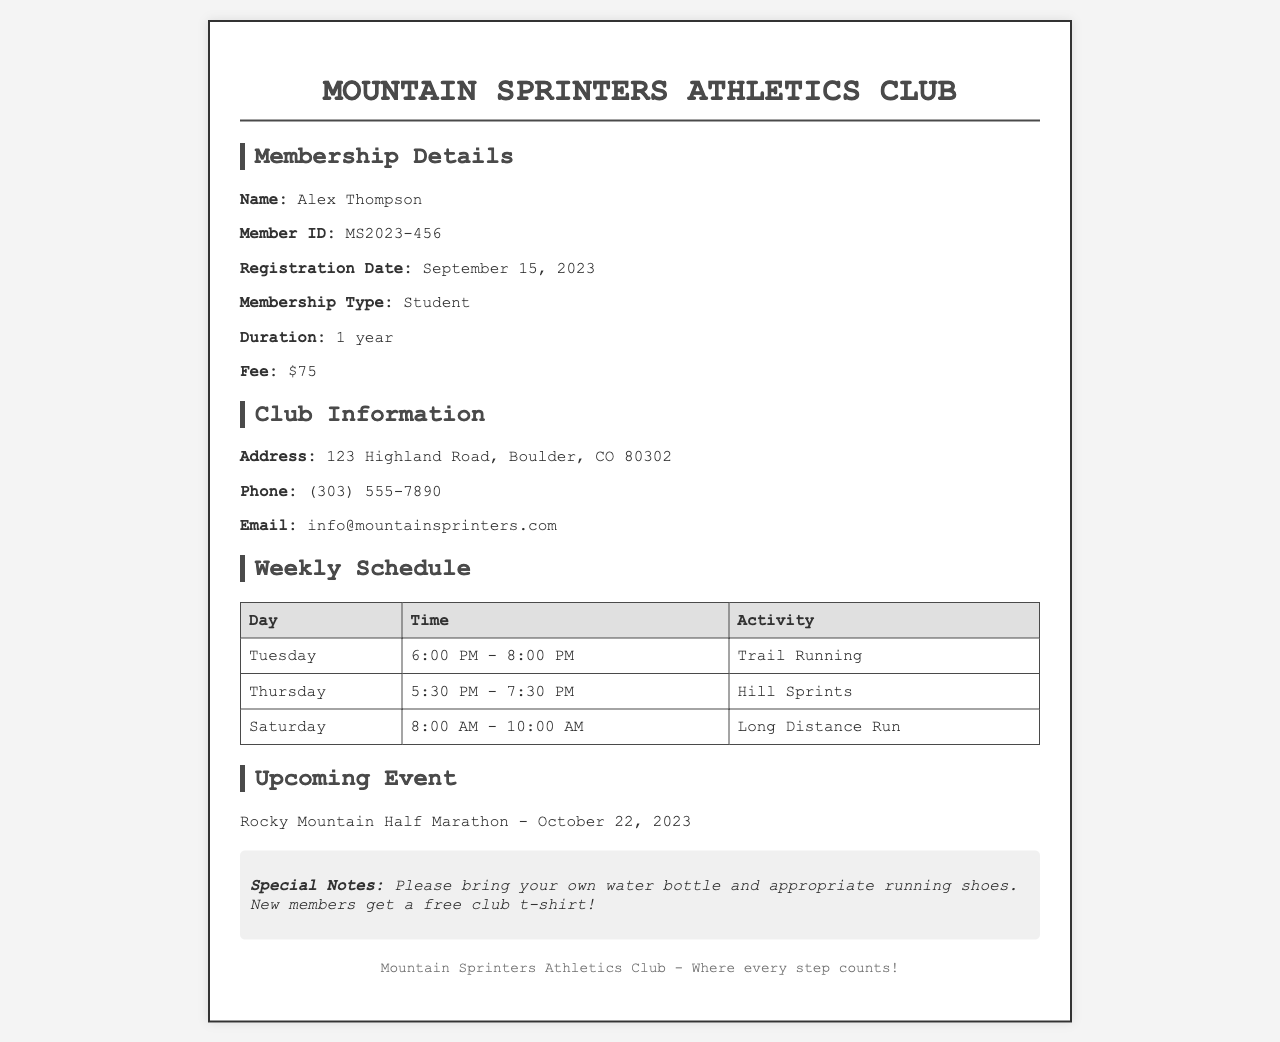What is the member's name? The member's name is specified in the membership details section of the document.
Answer: Alex Thompson What is the membership type? The membership type is mentioned under the membership details.
Answer: Student When was the registration date? The registration date is listed in the membership details section.
Answer: September 15, 2023 What is the fee for membership? The document states the fee for membership in the membership details section.
Answer: $75 What is the address of the club? The address is provided in the club information section of the document.
Answer: 123 Highland Road, Boulder, CO 80302 What day and time is the Long Distance Run scheduled? This information can be found in the weekly schedule table under the activities section.
Answer: Saturday, 8:00 AM - 10:00 AM Which event is upcoming? The upcoming event is specified in the event information section of the document.
Answer: Rocky Mountain Half Marathon How long is the membership duration? The duration is clearly stated in the membership details section of the document.
Answer: 1 year What special notes are mentioned? Special notes for members are given at the end of the document.
Answer: Bring your own water bottle and appropriate running shoes 